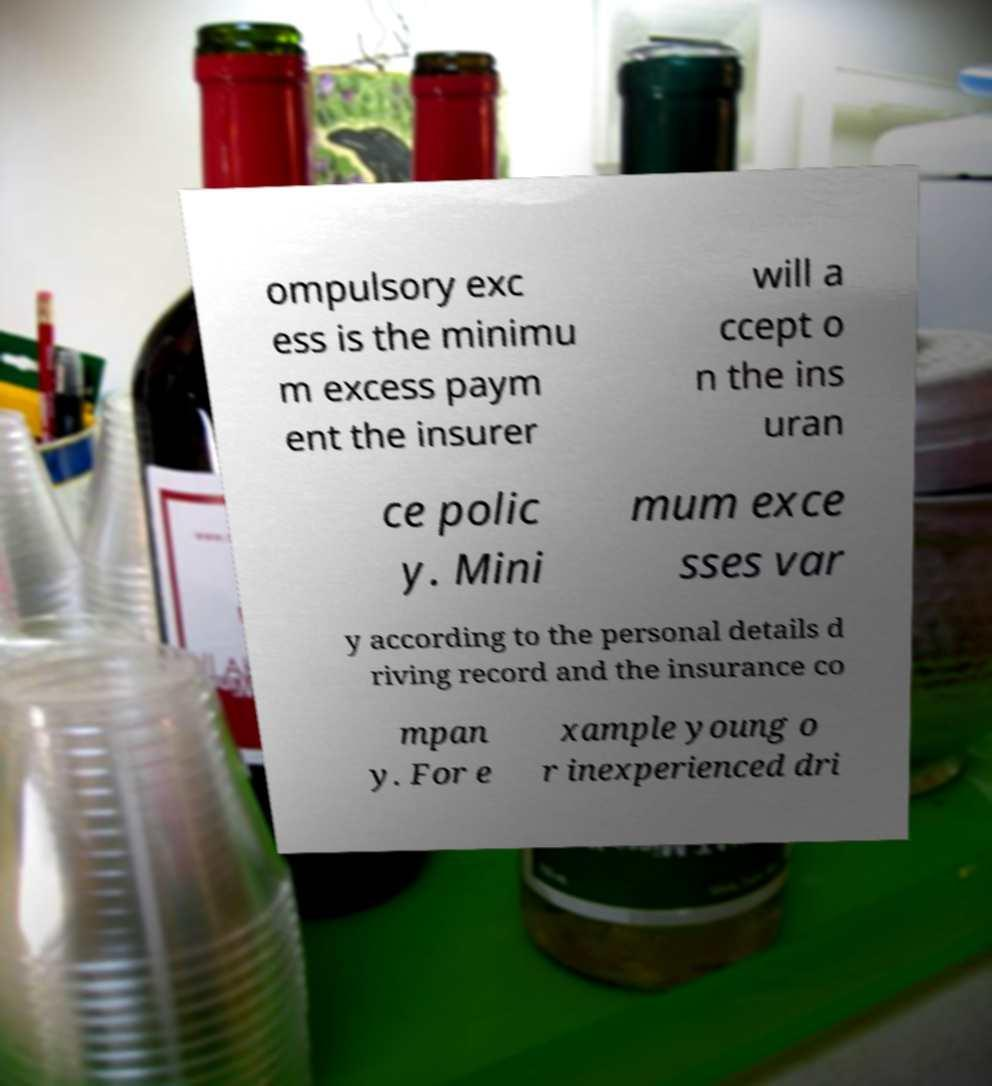There's text embedded in this image that I need extracted. Can you transcribe it verbatim? ompulsory exc ess is the minimu m excess paym ent the insurer will a ccept o n the ins uran ce polic y. Mini mum exce sses var y according to the personal details d riving record and the insurance co mpan y. For e xample young o r inexperienced dri 